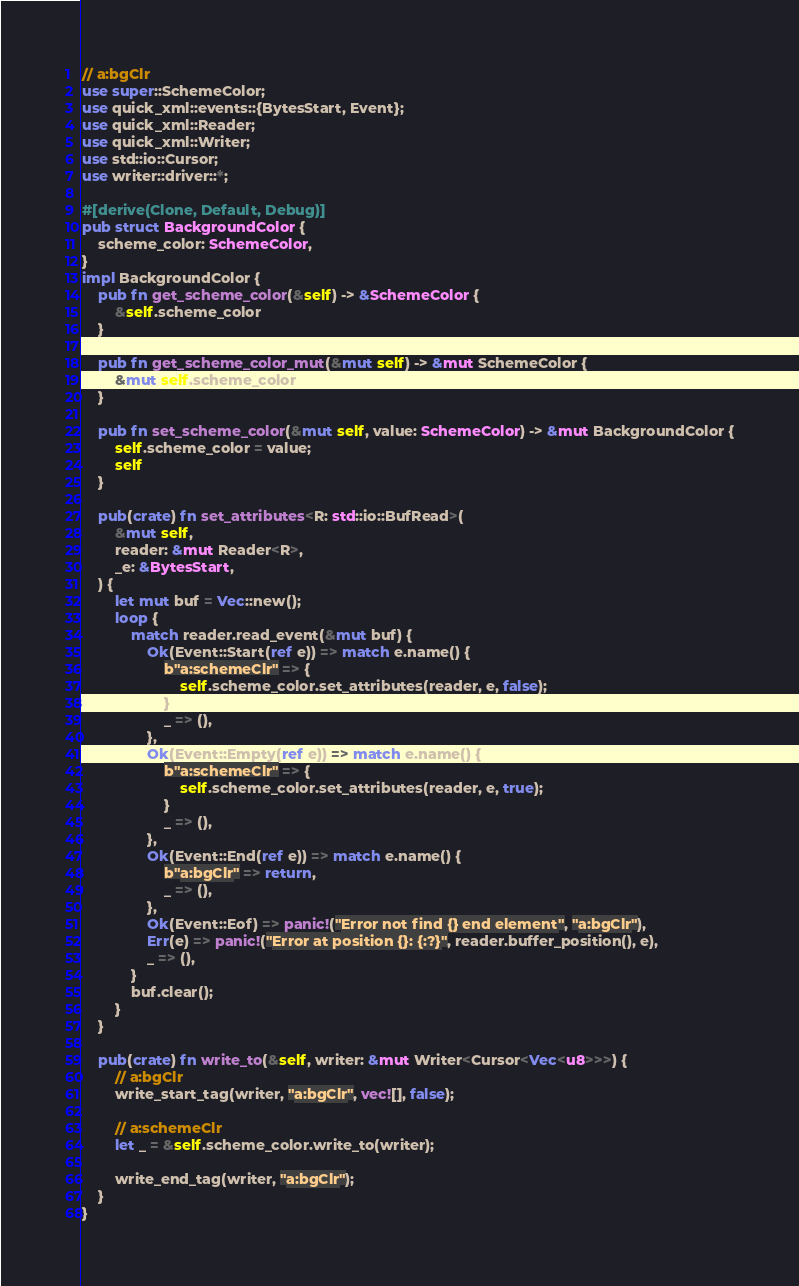<code> <loc_0><loc_0><loc_500><loc_500><_Rust_>// a:bgClr
use super::SchemeColor;
use quick_xml::events::{BytesStart, Event};
use quick_xml::Reader;
use quick_xml::Writer;
use std::io::Cursor;
use writer::driver::*;

#[derive(Clone, Default, Debug)]
pub struct BackgroundColor {
    scheme_color: SchemeColor,
}
impl BackgroundColor {
    pub fn get_scheme_color(&self) -> &SchemeColor {
        &self.scheme_color
    }

    pub fn get_scheme_color_mut(&mut self) -> &mut SchemeColor {
        &mut self.scheme_color
    }

    pub fn set_scheme_color(&mut self, value: SchemeColor) -> &mut BackgroundColor {
        self.scheme_color = value;
        self
    }

    pub(crate) fn set_attributes<R: std::io::BufRead>(
        &mut self,
        reader: &mut Reader<R>,
        _e: &BytesStart,
    ) {
        let mut buf = Vec::new();
        loop {
            match reader.read_event(&mut buf) {
                Ok(Event::Start(ref e)) => match e.name() {
                    b"a:schemeClr" => {
                        self.scheme_color.set_attributes(reader, e, false);
                    }
                    _ => (),
                },
                Ok(Event::Empty(ref e)) => match e.name() {
                    b"a:schemeClr" => {
                        self.scheme_color.set_attributes(reader, e, true);
                    }
                    _ => (),
                },
                Ok(Event::End(ref e)) => match e.name() {
                    b"a:bgClr" => return,
                    _ => (),
                },
                Ok(Event::Eof) => panic!("Error not find {} end element", "a:bgClr"),
                Err(e) => panic!("Error at position {}: {:?}", reader.buffer_position(), e),
                _ => (),
            }
            buf.clear();
        }
    }

    pub(crate) fn write_to(&self, writer: &mut Writer<Cursor<Vec<u8>>>) {
        // a:bgClr
        write_start_tag(writer, "a:bgClr", vec![], false);

        // a:schemeClr
        let _ = &self.scheme_color.write_to(writer);

        write_end_tag(writer, "a:bgClr");
    }
}
</code> 